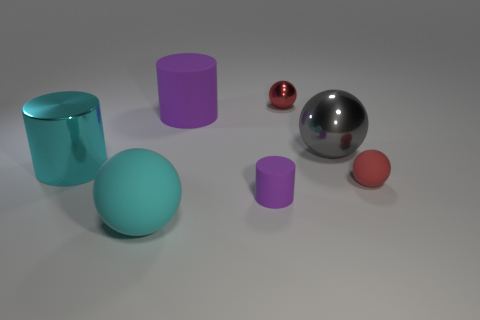Subtract all cyan spheres. How many spheres are left? 3 Subtract all red rubber balls. How many balls are left? 3 Subtract all yellow balls. Subtract all brown cubes. How many balls are left? 4 Add 2 large yellow rubber things. How many objects exist? 9 Subtract all balls. How many objects are left? 3 Subtract all red matte balls. Subtract all red things. How many objects are left? 4 Add 5 cylinders. How many cylinders are left? 8 Add 7 gray metal objects. How many gray metal objects exist? 8 Subtract 0 purple blocks. How many objects are left? 7 